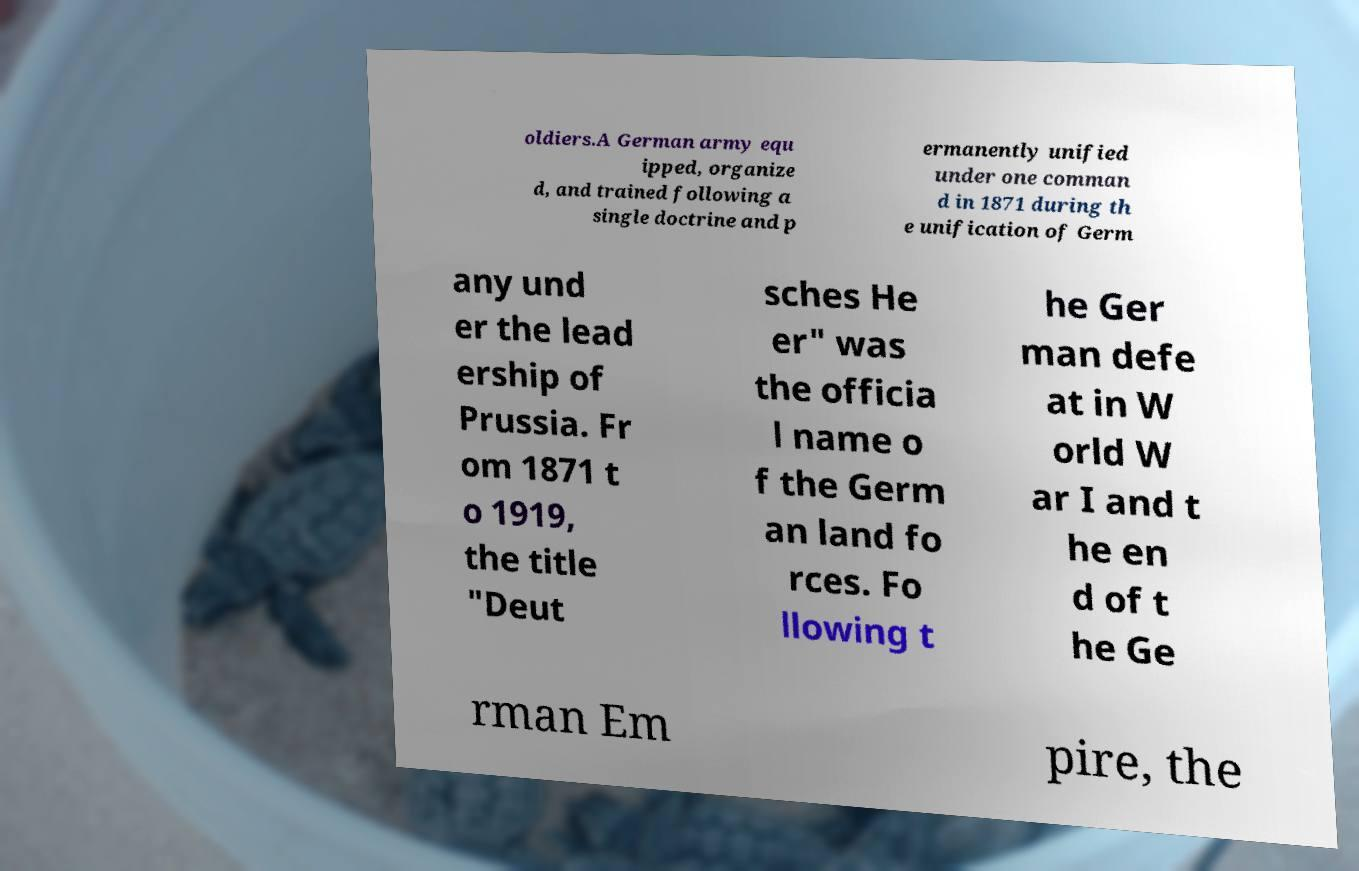What messages or text are displayed in this image? I need them in a readable, typed format. oldiers.A German army equ ipped, organize d, and trained following a single doctrine and p ermanently unified under one comman d in 1871 during th e unification of Germ any und er the lead ership of Prussia. Fr om 1871 t o 1919, the title "Deut sches He er" was the officia l name o f the Germ an land fo rces. Fo llowing t he Ger man defe at in W orld W ar I and t he en d of t he Ge rman Em pire, the 